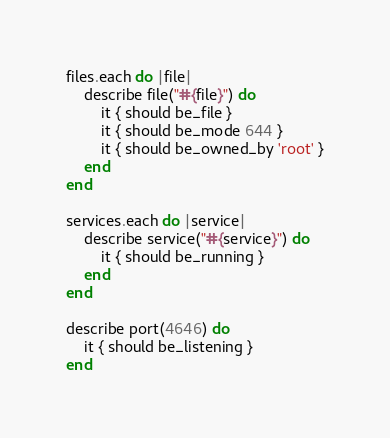<code> <loc_0><loc_0><loc_500><loc_500><_Ruby_>files.each do |file|
    describe file("#{file}") do
        it { should be_file }
        it { should be_mode 644 }
        it { should be_owned_by 'root' }
    end
end

services.each do |service|
    describe service("#{service}") do
        it { should be_running }
    end
end

describe port(4646) do
    it { should be_listening }
end
</code> 